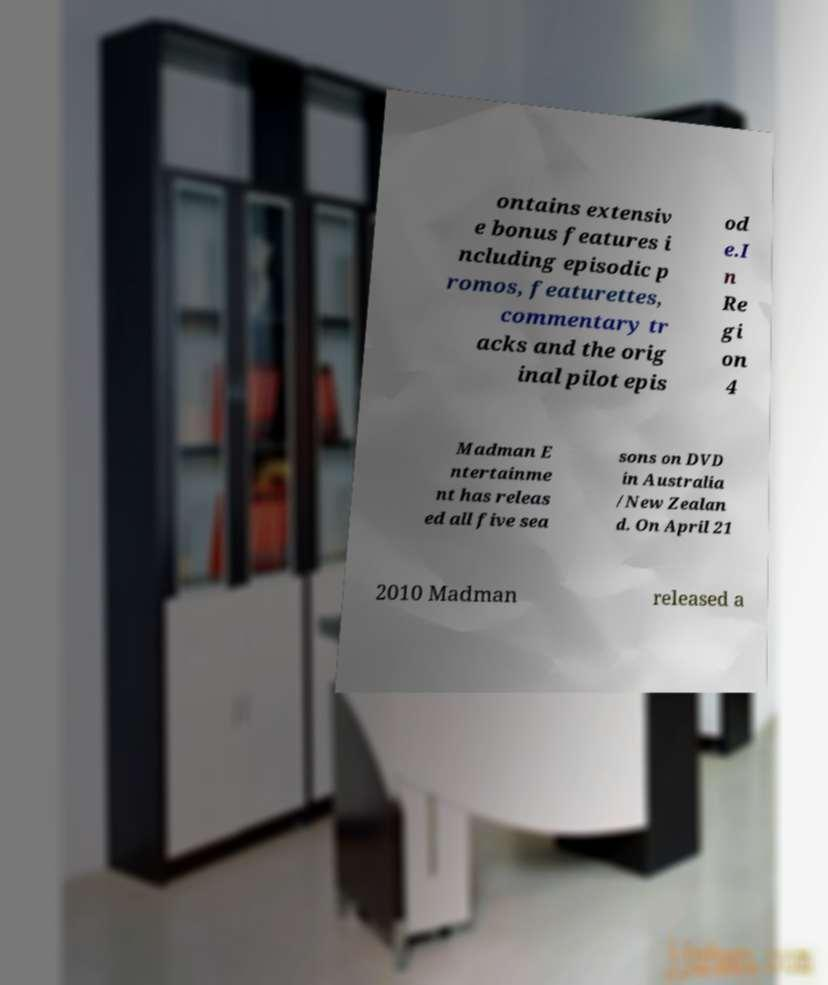Please read and relay the text visible in this image. What does it say? ontains extensiv e bonus features i ncluding episodic p romos, featurettes, commentary tr acks and the orig inal pilot epis od e.I n Re gi on 4 Madman E ntertainme nt has releas ed all five sea sons on DVD in Australia /New Zealan d. On April 21 2010 Madman released a 